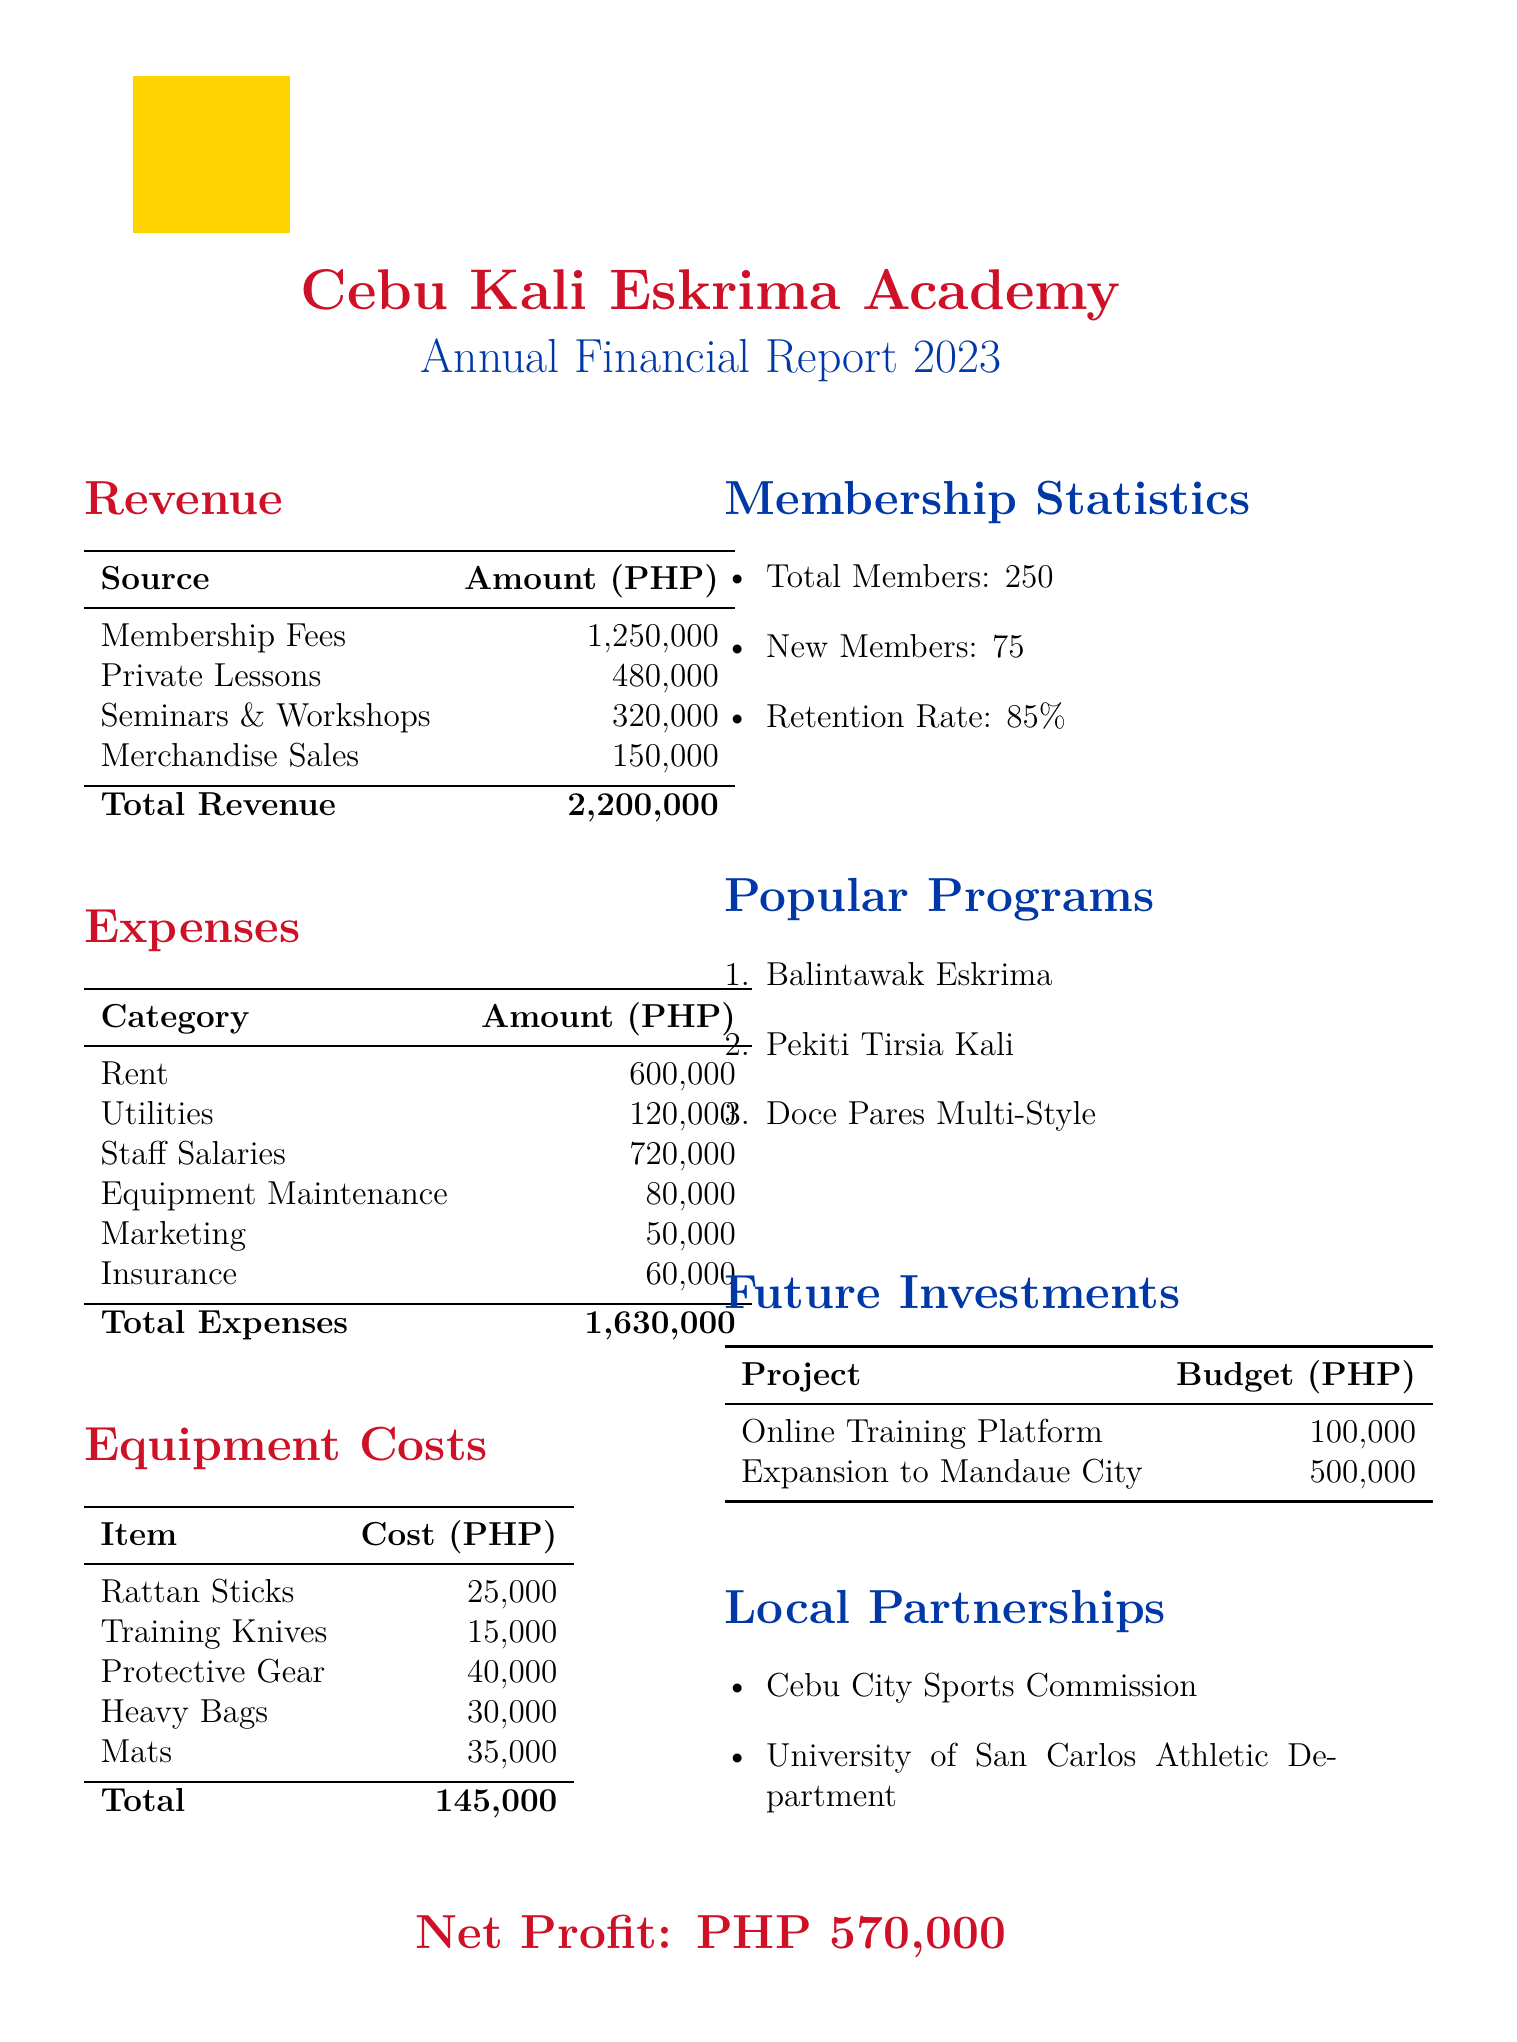what is the total revenue? The total revenue is the sum of all revenue sources in the document: 1,250,000 + 480,000 + 320,000 + 150,000 = 2,200,000.
Answer: 2,200,000 what is the total cost of protective gear? The protective gear cost is specifically mentioned in the equipment costs section, which is 40,000.
Answer: 40,000 how many total members does the training center have? The total members are listed in the membership statistics section, which shows a total of 250 members.
Answer: 250 what is the retention rate? The retention rate is mentioned in the membership statistics section and is stated as 85%.
Answer: 85% what are the future investment projects planned? The future investments listed include Online Training Platform and Expansion to Mandaue City with their respective budgets.
Answer: Online Training Platform, Expansion to Mandaue City what is the total equipment cost? The total equipment cost is the sum of all individual equipment costs listed in the equipment costs section: 25,000 + 15,000 + 40,000 + 30,000 + 35,000 = 145,000.
Answer: 145,000 who are the local partnerships mentioned? The local partnerships section lists Cebu City Sports Commission and University of San Carlos Athletic Department as partners.
Answer: Cebu City Sports Commission, University of San Carlos Athletic Department what is the total annual expense? The total annual expense is the sum of all expense categories listed in the expenses section, which totals 1,630,000.
Answer: 1,630,000 what is the net profit for the fiscal year? The net profit is calculated as total revenue minus total expenses, which is 2,200,000 - 1,630,000 = 570,000.
Answer: 570,000 